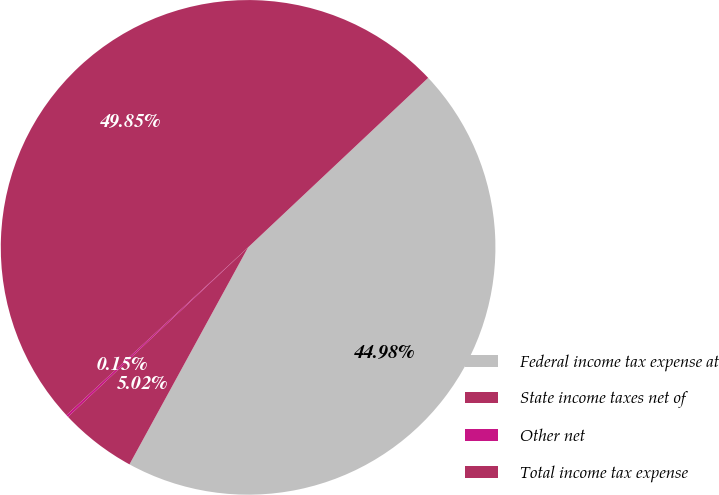Convert chart. <chart><loc_0><loc_0><loc_500><loc_500><pie_chart><fcel>Federal income tax expense at<fcel>State income taxes net of<fcel>Other net<fcel>Total income tax expense<nl><fcel>44.98%<fcel>5.02%<fcel>0.15%<fcel>49.85%<nl></chart> 